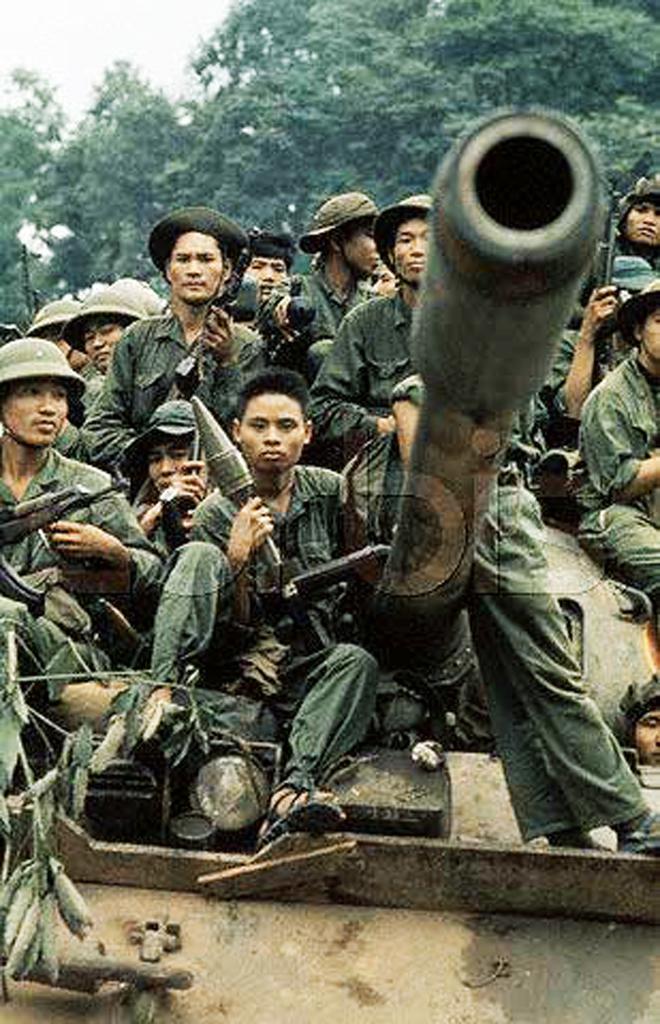Can you describe this image briefly? In this image we can see some people wearing uniform and among them few people holding some objects and there is a vehicle which looks like a tank. There are some trees in the background and we can see the sky. 